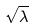<formula> <loc_0><loc_0><loc_500><loc_500>\sqrt { \lambda }</formula> 